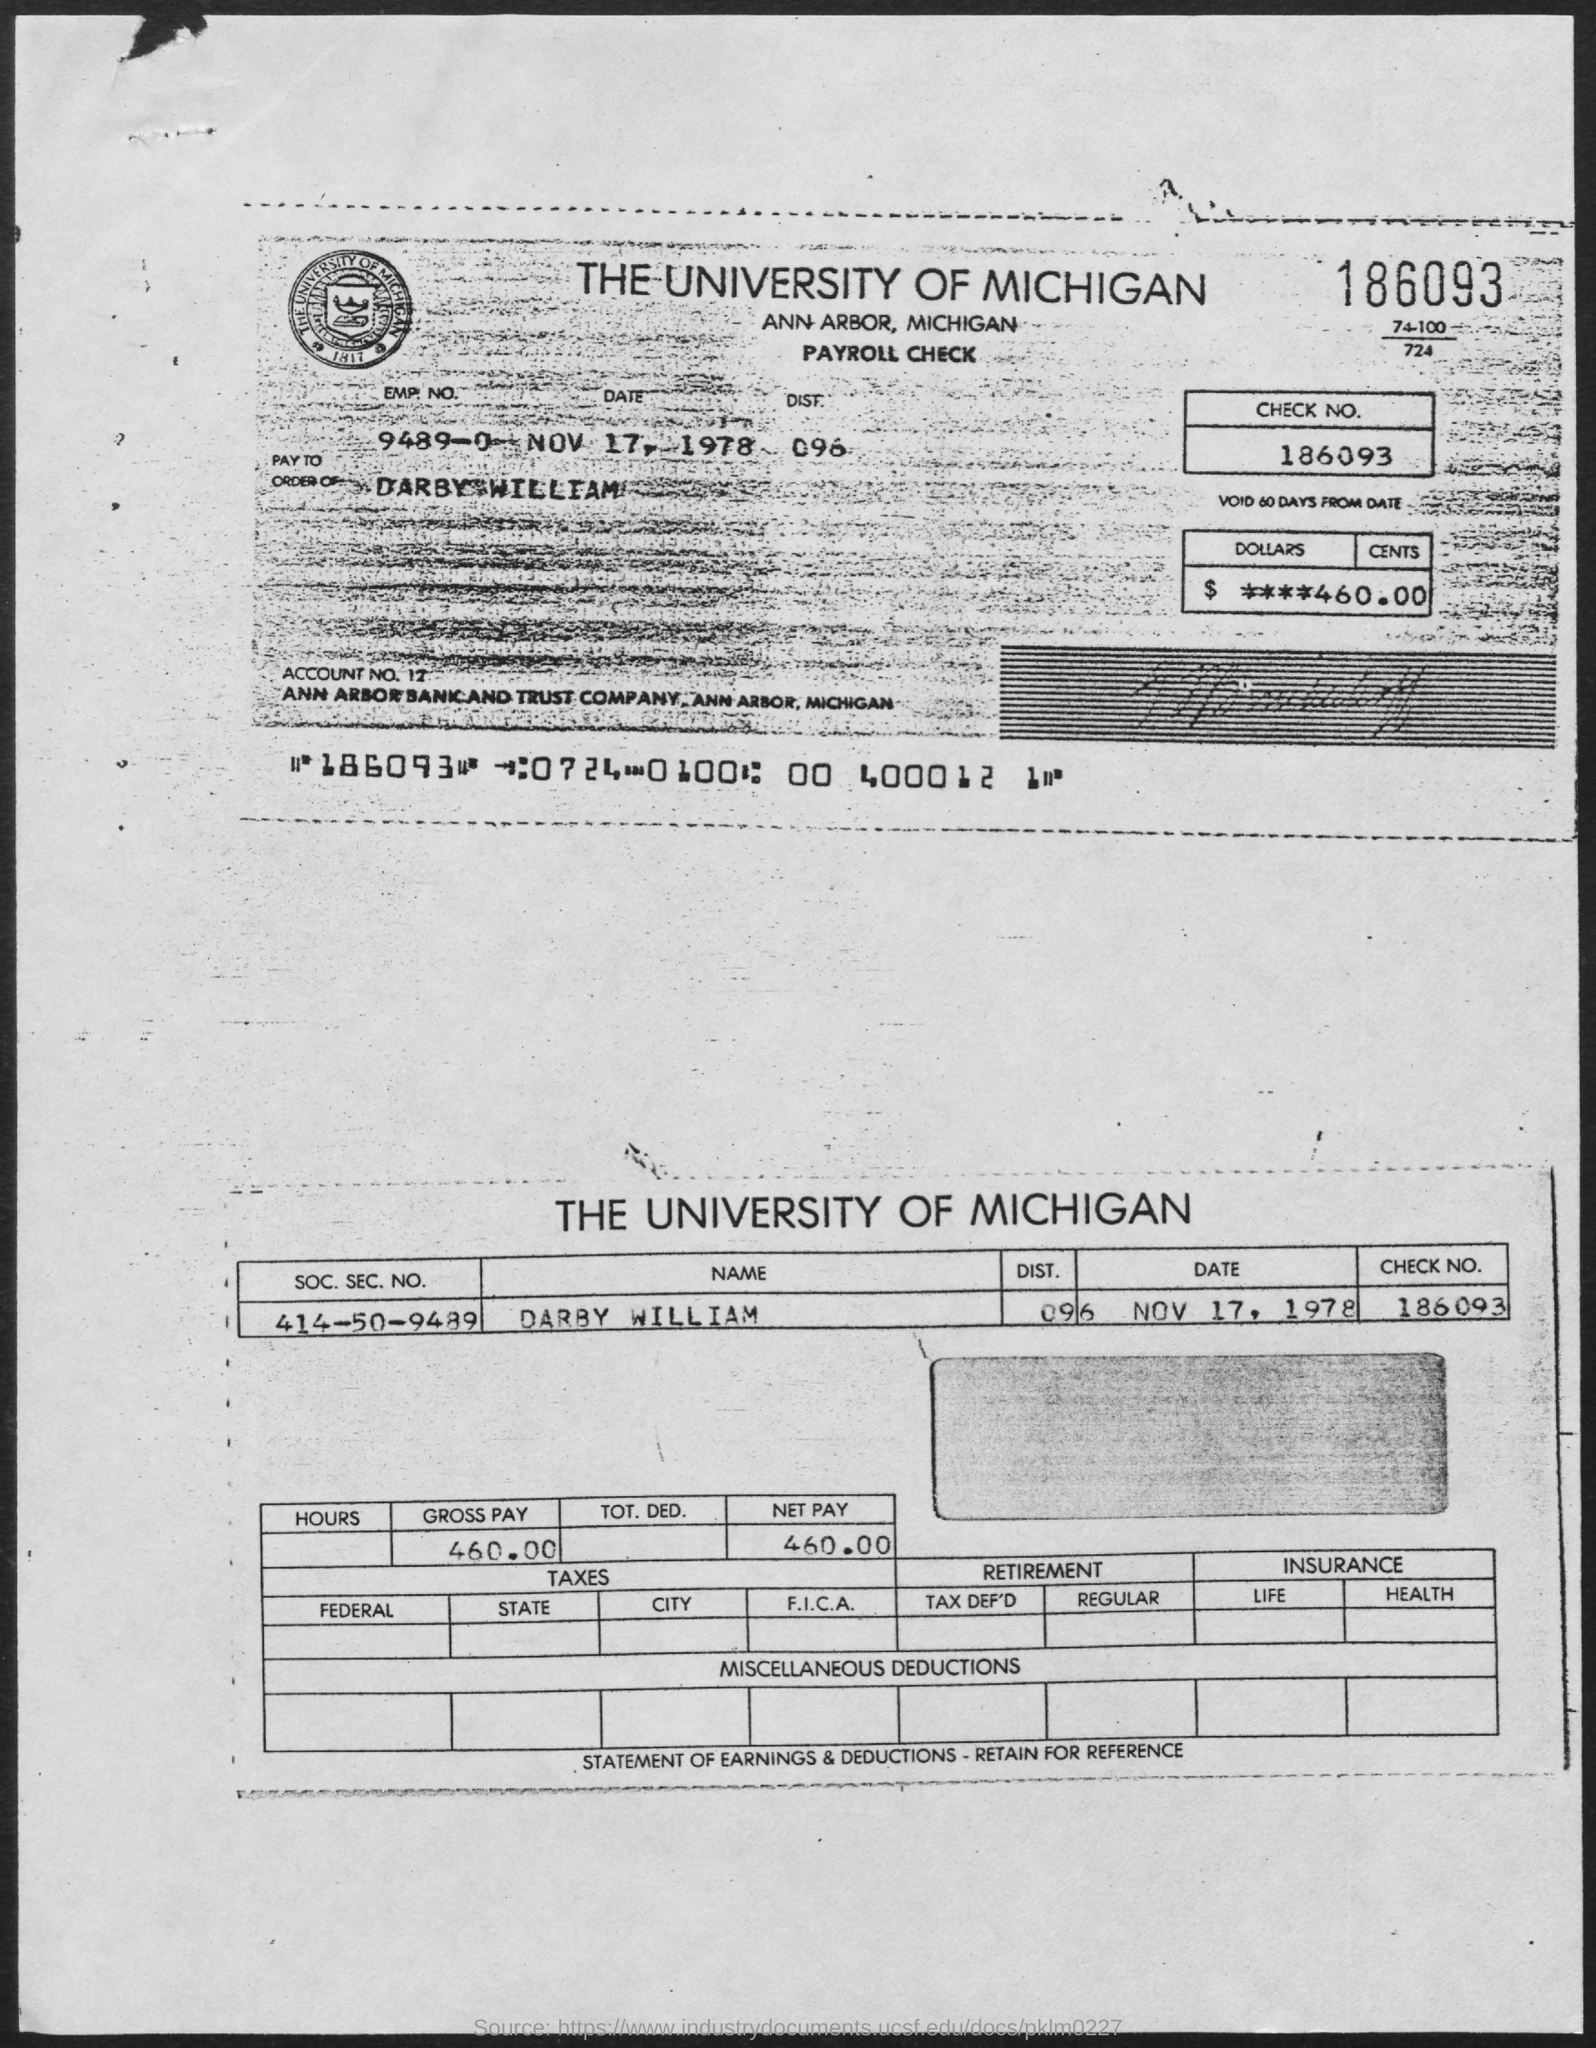Mention a couple of crucial points in this snapshot. The gross pay is 460.00. The name of the university is The University of Michigan. The pay order mentions the name of Darby William. The amount is $460.00 in dollars and cents. The net pay is 460.00. 